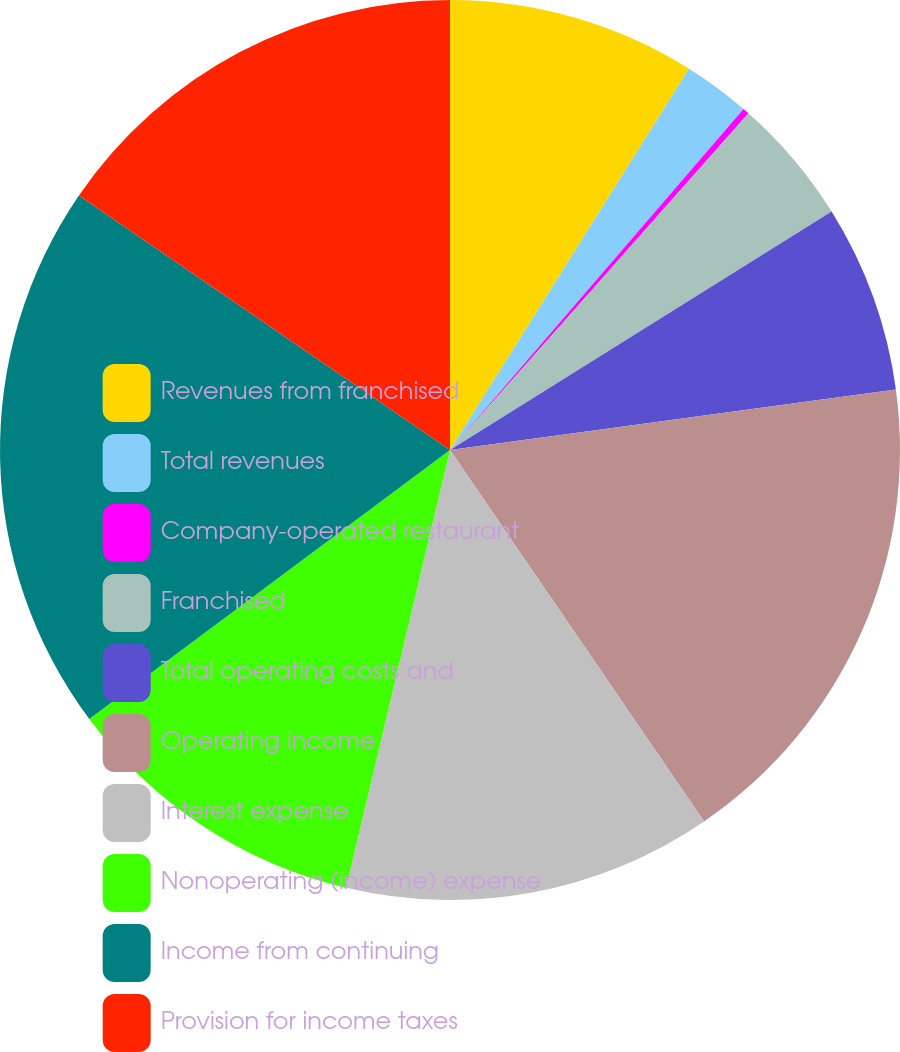Convert chart to OTSL. <chart><loc_0><loc_0><loc_500><loc_500><pie_chart><fcel>Revenues from franchised<fcel>Total revenues<fcel>Company-operated restaurant<fcel>Franchised<fcel>Total operating costs and<fcel>Operating income<fcel>Interest expense<fcel>Nonoperating (income) expense<fcel>Income from continuing<fcel>Provision for income taxes<nl><fcel>8.91%<fcel>2.4%<fcel>0.23%<fcel>4.57%<fcel>6.74%<fcel>17.6%<fcel>13.26%<fcel>11.09%<fcel>19.77%<fcel>15.43%<nl></chart> 